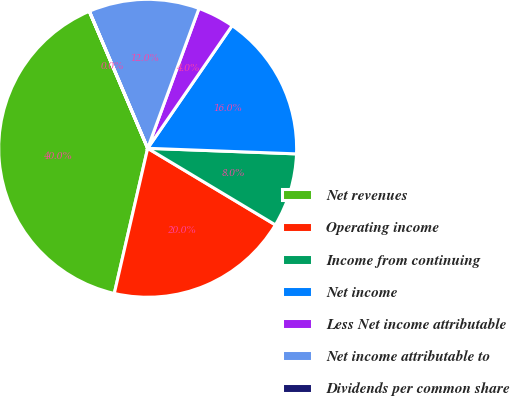<chart> <loc_0><loc_0><loc_500><loc_500><pie_chart><fcel>Net revenues<fcel>Operating income<fcel>Income from continuing<fcel>Net income<fcel>Less Net income attributable<fcel>Net income attributable to<fcel>Dividends per common share<nl><fcel>39.99%<fcel>20.0%<fcel>8.0%<fcel>16.0%<fcel>4.0%<fcel>12.0%<fcel>0.01%<nl></chart> 